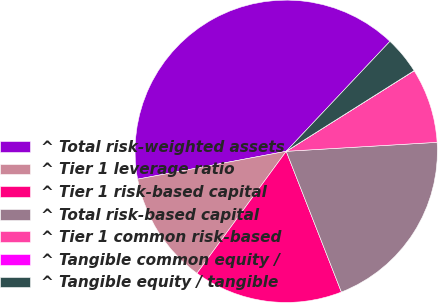<chart> <loc_0><loc_0><loc_500><loc_500><pie_chart><fcel>^ Total risk-weighted assets<fcel>^ Tier 1 leverage ratio<fcel>^ Tier 1 risk-based capital<fcel>^ Total risk-based capital<fcel>^ Tier 1 common risk-based<fcel>^ Tangible common equity /<fcel>^ Tangible equity / tangible<nl><fcel>39.99%<fcel>12.0%<fcel>16.0%<fcel>20.0%<fcel>8.0%<fcel>0.01%<fcel>4.01%<nl></chart> 